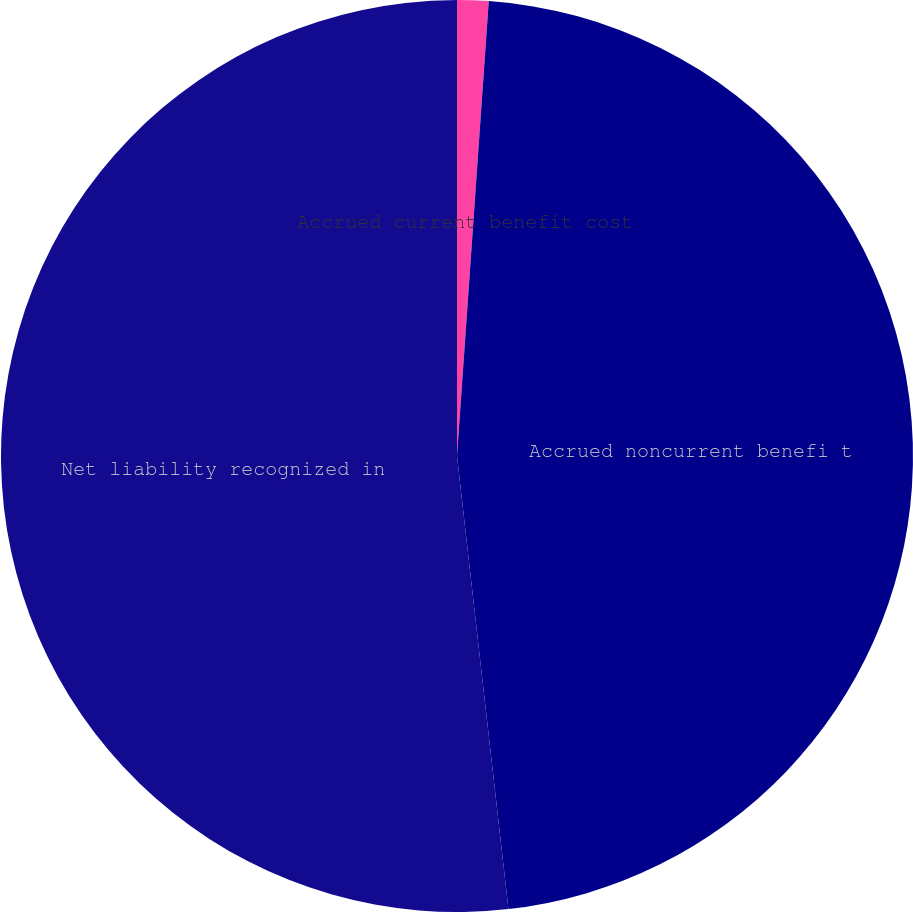Convert chart. <chart><loc_0><loc_0><loc_500><loc_500><pie_chart><fcel>Accrued current benefit cost<fcel>Accrued noncurrent benefi t<fcel>Net liability recognized in<nl><fcel>1.11%<fcel>47.09%<fcel>51.8%<nl></chart> 